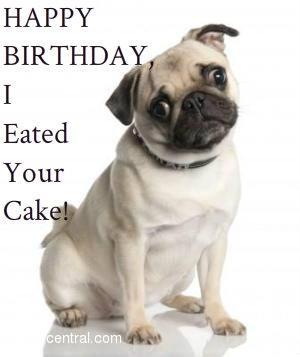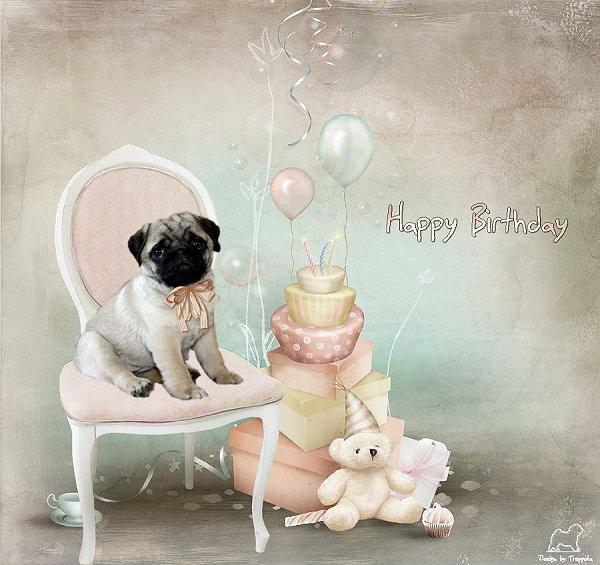The first image is the image on the left, the second image is the image on the right. Evaluate the accuracy of this statement regarding the images: "One of the dogs is lying down.". Is it true? Answer yes or no. No. The first image is the image on the left, the second image is the image on the right. Considering the images on both sides, is "One image shows a buff-beige pug with its head turned to the side and its tongue sticking out." valid? Answer yes or no. No. 